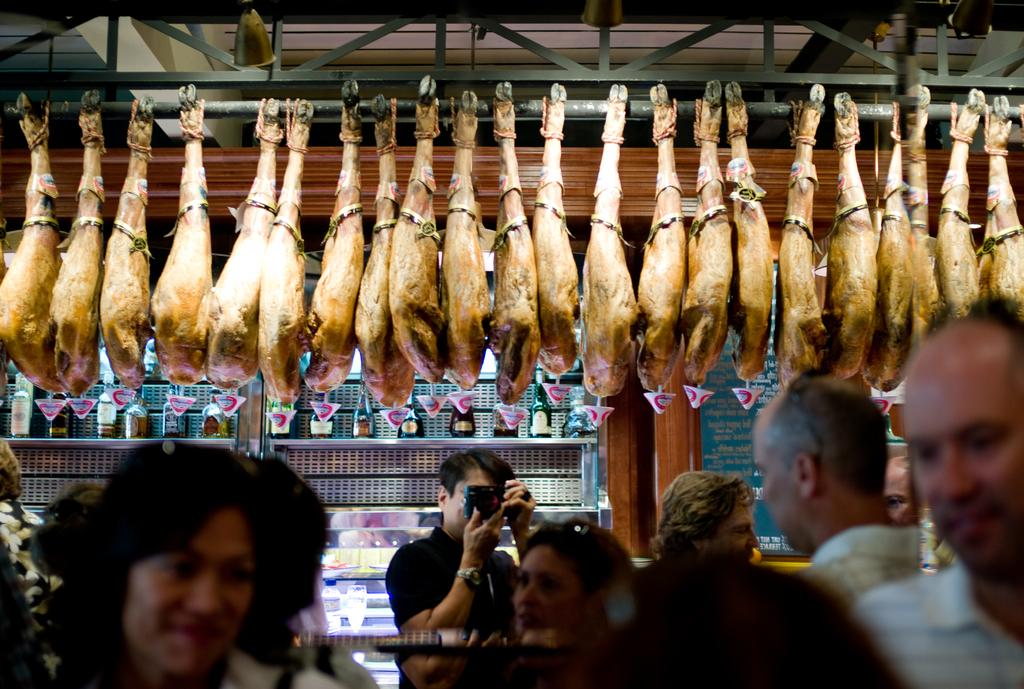How many persons are in the image? There are persons in the image, but the exact number is not specified. What type of food is visible in the image? There is meat of an animal in the image. What can be seen in the background of the image? There are bottles on a rack and a board in the background of the image. What type of fork is being used for digestion in the image? There is no fork or mention of digestion in the image. 